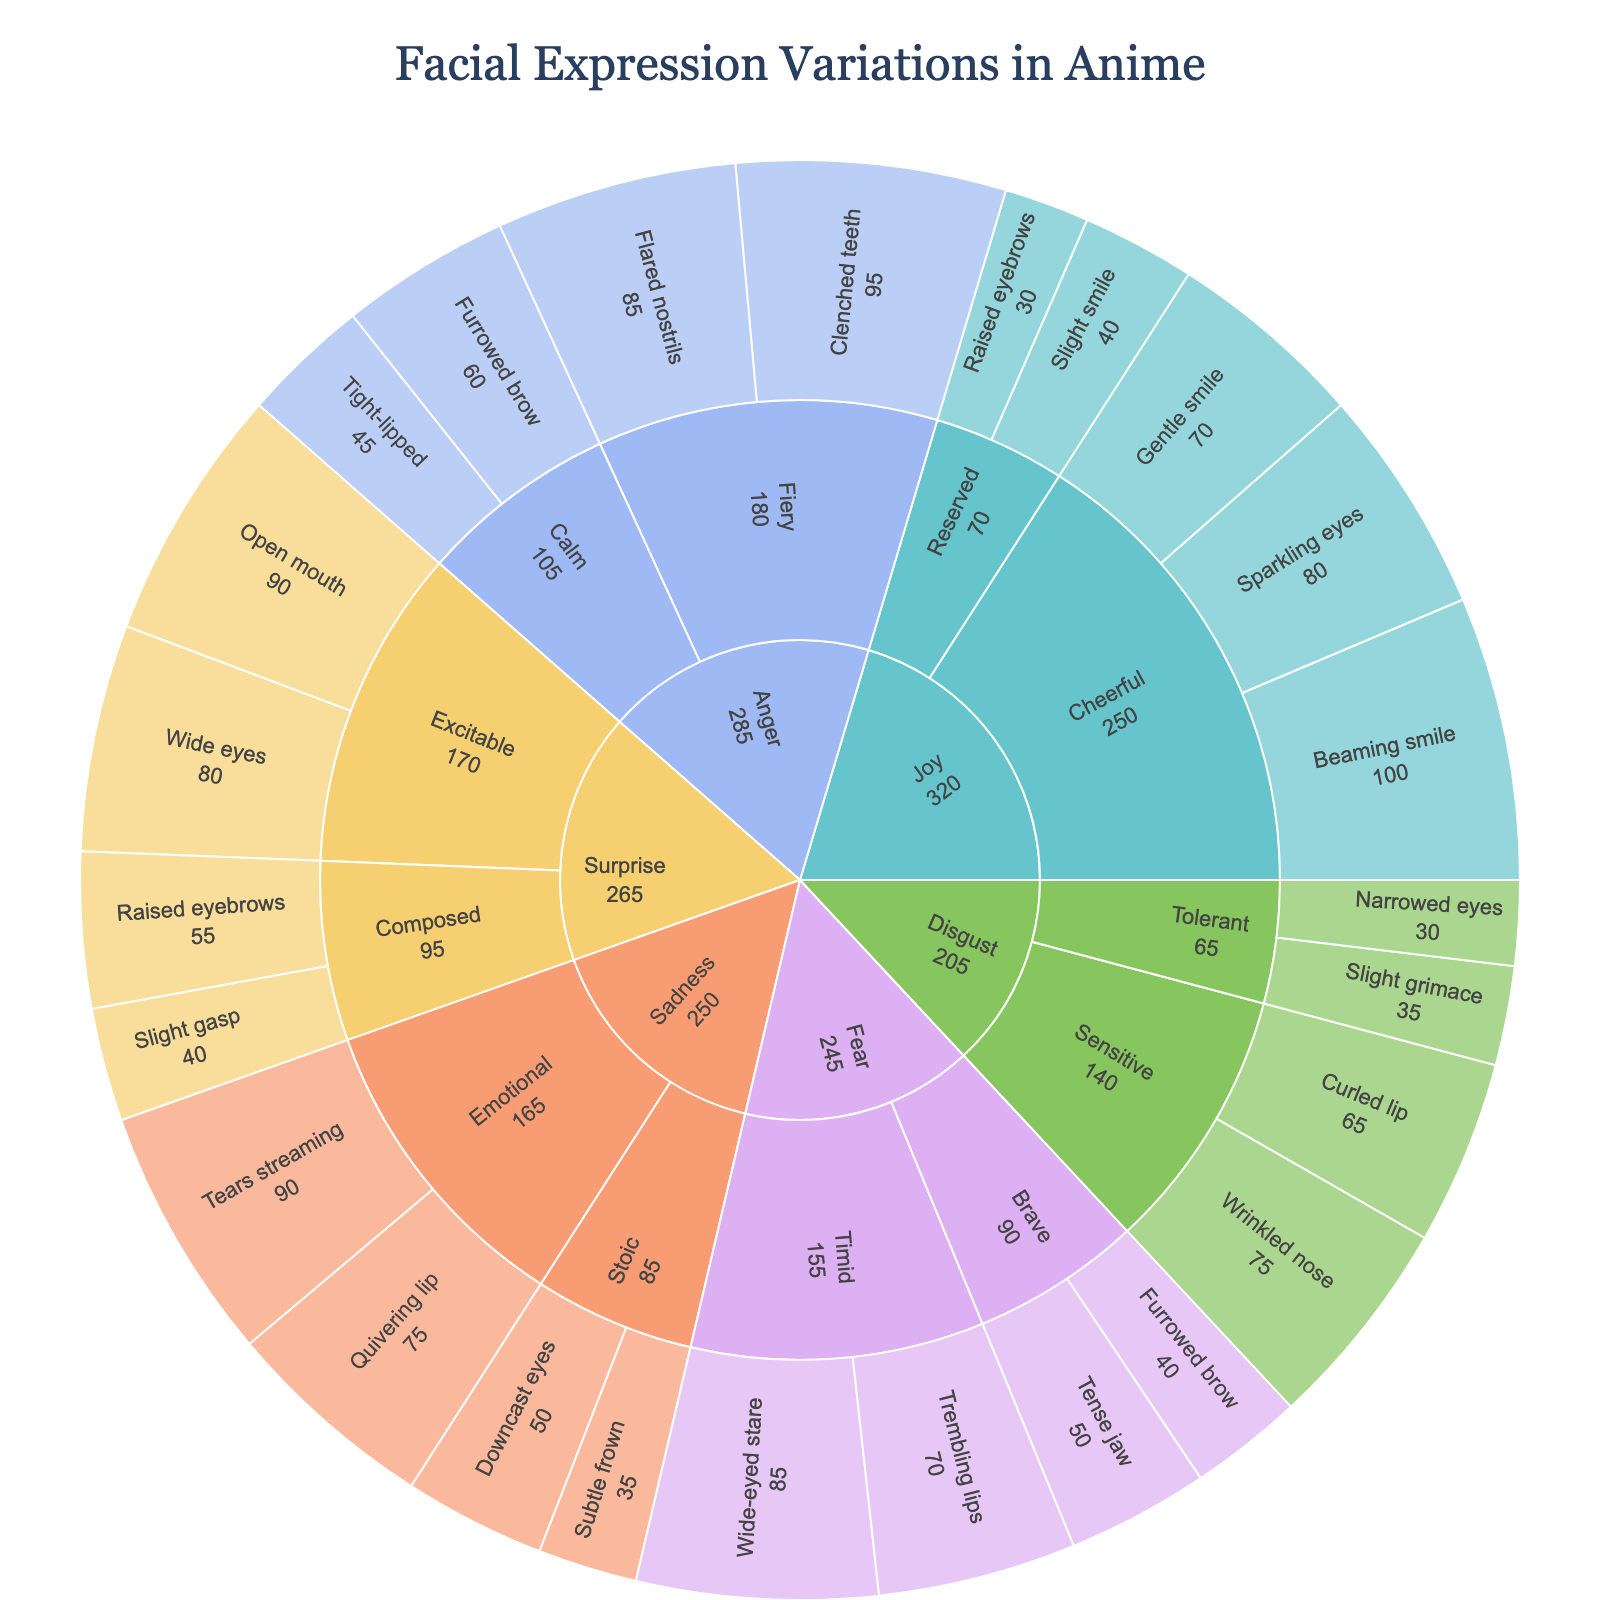what is the title of the plot? The title of the plot is displayed at the top of the figure.
Answer: Facial Expression Variations in Anime Which emotion has the highest intensity expression? By looking at the sunburst plot, identify the segment with the highest value.
Answer: Joy (Beaming smile, 100) How many personality types are present for the emotion Fear? Navigate to the Fear segment and count the different sub-segments representing personality types.
Answer: 2 (Timid, Brave) For the personality type "Cheerful" under Joy, what is the combined intensity of all expressions? Sum the intensity values of Beaming smile (100), Gentle smile (70), and Sparkling eyes (80).
Answer: 250 Which personality type has the lowest intensity expression under the emotion Anger? Look at the segments within Anger and compare the lowest value.
Answer: Calm (Tight-lipped, 45) For the emotion Sadness, what is the difference in intensity between the highest and lowest expressions? Subtract the lowest intensity value (Subtle frown, 35) from the highest (Tears streaming, 90).
Answer: 55 Which expression under the emotion Surprise has a higher intensity: Wide eyes or Open mouth? Compare intensity values of Wide eyes (80) and Open mouth (90).
Answer: Open mouth How does the intensity of the highest expression in Disgust compare to the highest in Fear? Compare the maximum intensity values: Disgust (Wrinkled nose, 75) and Fear (Wide-eyed stare, 85).
Answer: Fear is higher Which emotion has more equally distributed intensity values: Anger or Joy? Evaluate the spread of intensity values in the segments under each emotion. Joy has a wider spread with values ranging from 30 to 100, while Anger ranges from 45 to 95.
Answer: Anger 